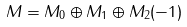Convert formula to latex. <formula><loc_0><loc_0><loc_500><loc_500>M = M _ { 0 } \oplus M _ { 1 } \oplus M _ { 2 } ( - 1 )</formula> 